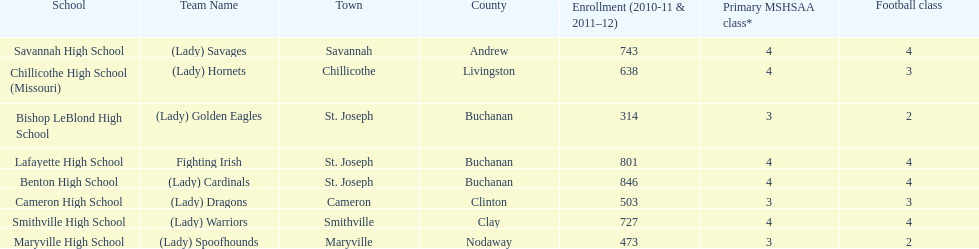Which school has the least amount of student enrollment between 2010-2011 and 2011-2012? Bishop LeBlond High School. Parse the full table. {'header': ['School', 'Team Name', 'Town', 'County', 'Enrollment (2010-11 & 2011–12)', 'Primary MSHSAA class*', 'Football class'], 'rows': [['Savannah High School', '(Lady) Savages', 'Savannah', 'Andrew', '743', '4', '4'], ['Chillicothe High School (Missouri)', '(Lady) Hornets', 'Chillicothe', 'Livingston', '638', '4', '3'], ['Bishop LeBlond High School', '(Lady) Golden Eagles', 'St. Joseph', 'Buchanan', '314', '3', '2'], ['Lafayette High School', 'Fighting Irish', 'St. Joseph', 'Buchanan', '801', '4', '4'], ['Benton High School', '(Lady) Cardinals', 'St. Joseph', 'Buchanan', '846', '4', '4'], ['Cameron High School', '(Lady) Dragons', 'Cameron', 'Clinton', '503', '3', '3'], ['Smithville High School', '(Lady) Warriors', 'Smithville', 'Clay', '727', '4', '4'], ['Maryville High School', '(Lady) Spoofhounds', 'Maryville', 'Nodaway', '473', '3', '2']]} 